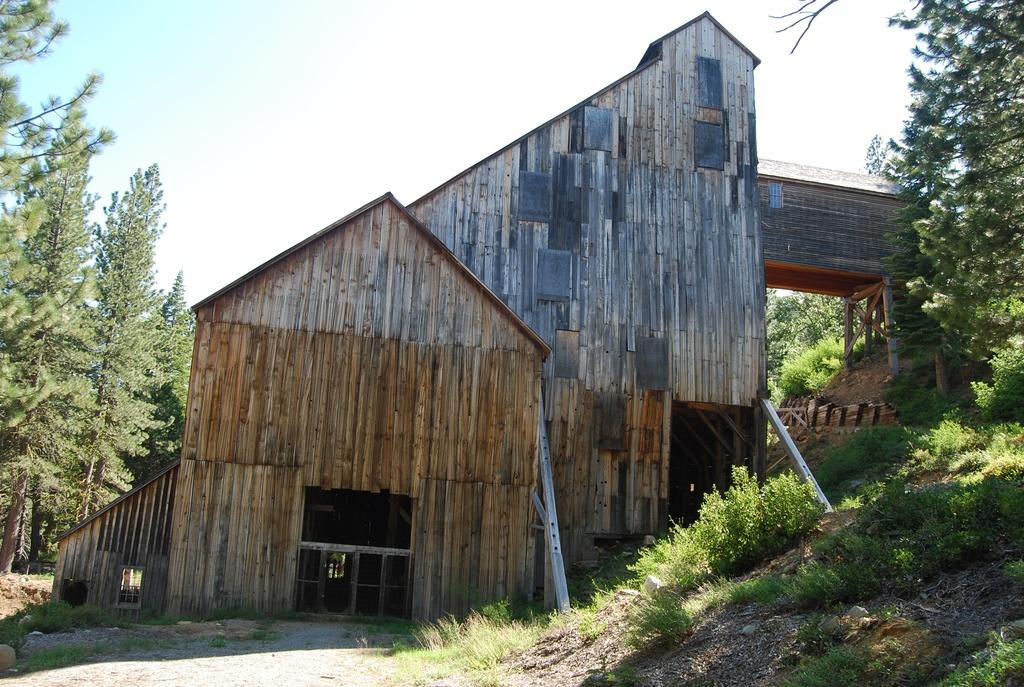What type of building is in the image? There is a wooden building in the image. What can be seen on the ground in the image? There is grass visible in the image, as well as other objects on the ground. What other natural elements are present in the image? There are trees in the image. What is visible in the background of the image? The sky is visible in the background of the image. How does the moon affect the growth of the tree in the image? The image does not depict a moon or a tree, so it is not possible to determine any effects on the tree's growth. 